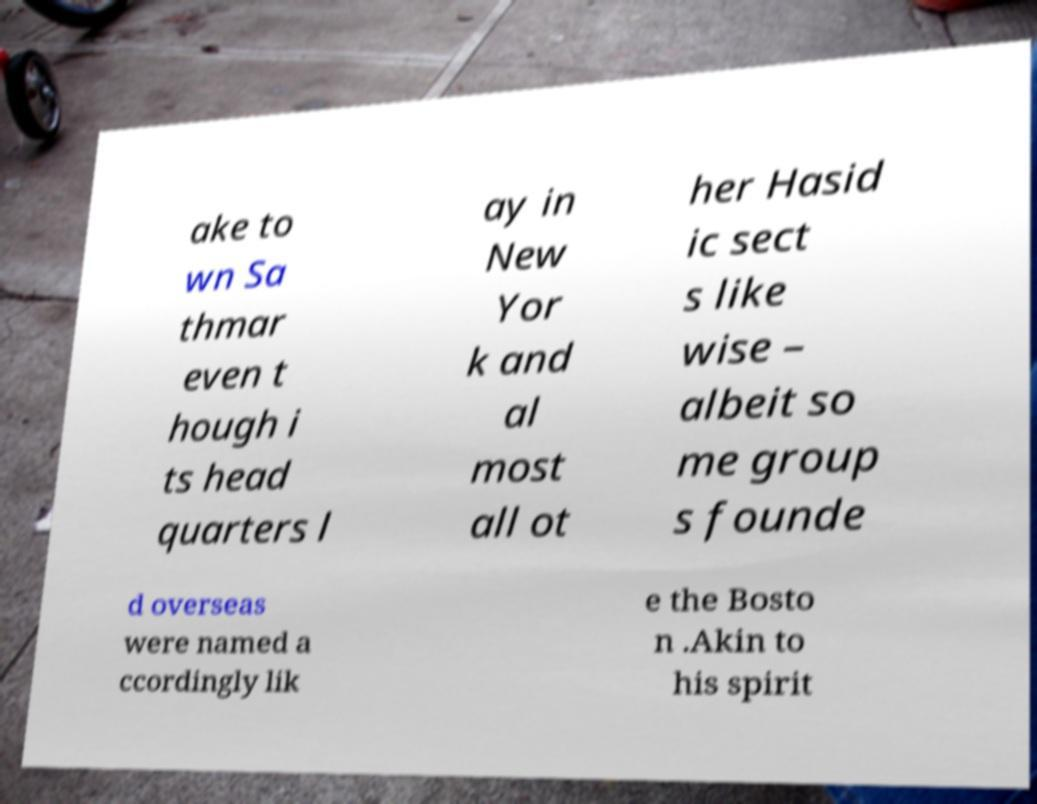What messages or text are displayed in this image? I need them in a readable, typed format. ake to wn Sa thmar even t hough i ts head quarters l ay in New Yor k and al most all ot her Hasid ic sect s like wise – albeit so me group s founde d overseas were named a ccordingly lik e the Bosto n .Akin to his spirit 